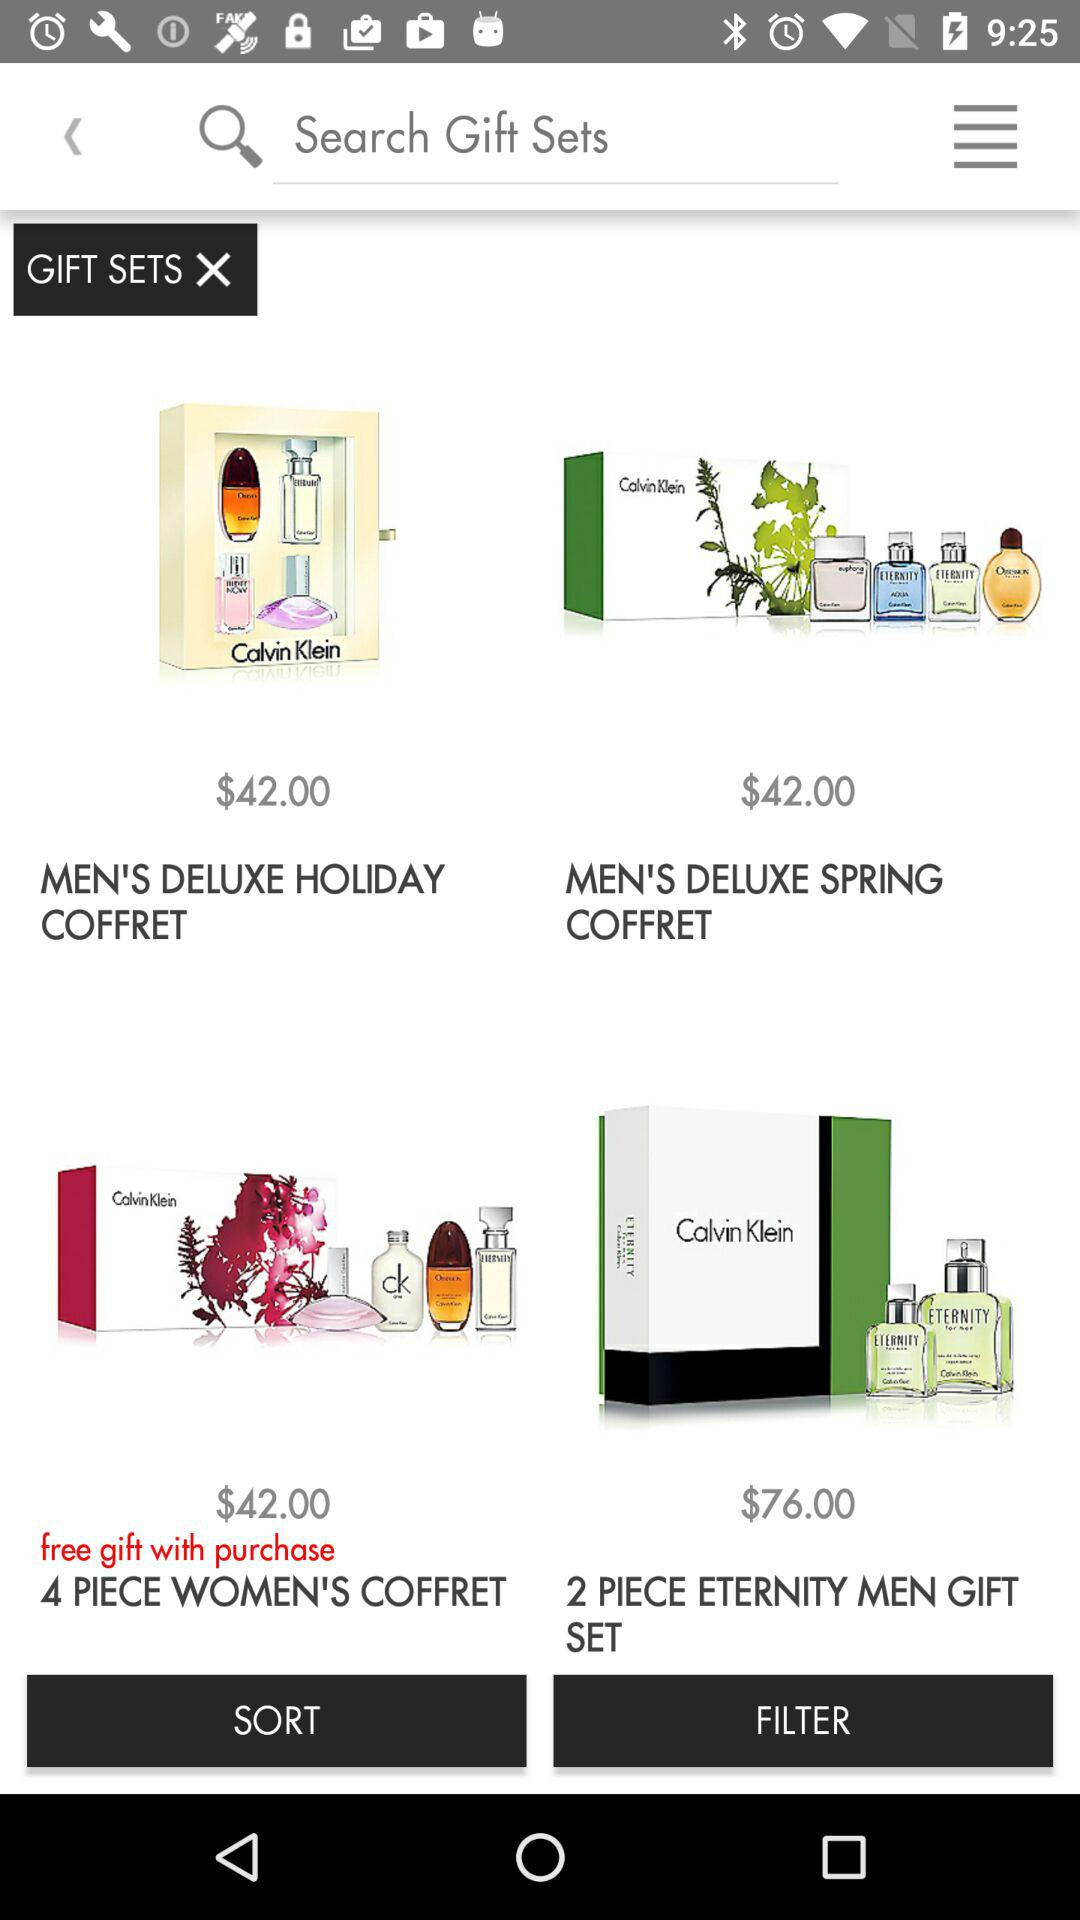How much more expensive is the most expensive gift set than the least expensive gift set?
Answer the question using a single word or phrase. $34.00 